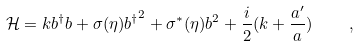Convert formula to latex. <formula><loc_0><loc_0><loc_500><loc_500>\mathcal { H } = k b ^ { \dagger } b + \sigma ( \eta ) { b ^ { \dagger } } ^ { 2 } + \sigma ^ { * } ( \eta ) b ^ { 2 } + \frac { i } { 2 } ( k + \frac { a ^ { \prime } } { a } ) \quad ,</formula> 